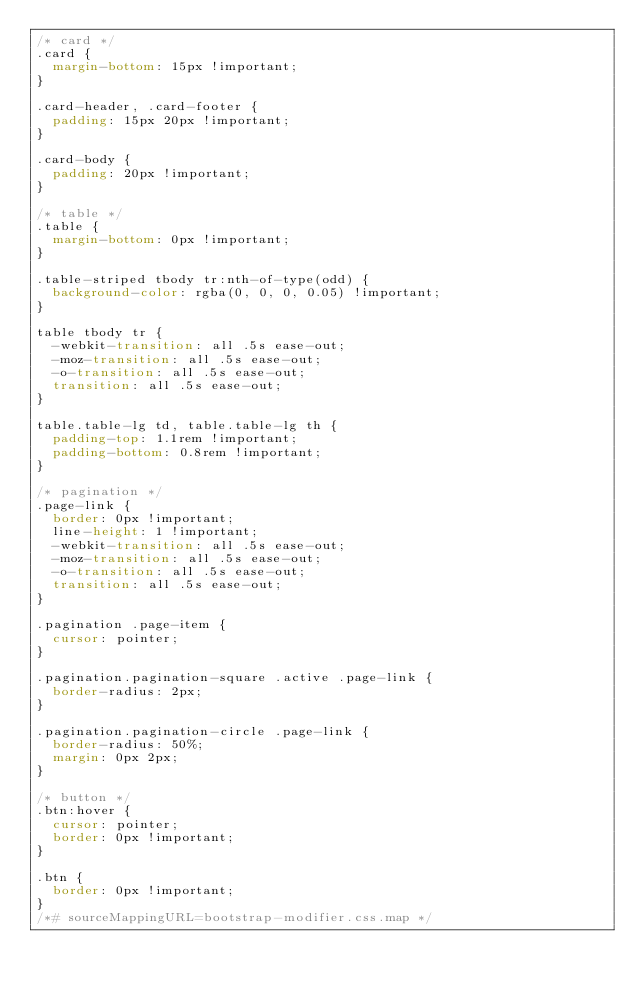Convert code to text. <code><loc_0><loc_0><loc_500><loc_500><_CSS_>/* card */
.card {
  margin-bottom: 15px !important;
}

.card-header, .card-footer {
  padding: 15px 20px !important;
}

.card-body {
  padding: 20px !important;
}

/* table */
.table {
  margin-bottom: 0px !important;
}

.table-striped tbody tr:nth-of-type(odd) {
  background-color: rgba(0, 0, 0, 0.05) !important;
}

table tbody tr {
  -webkit-transition: all .5s ease-out;
  -moz-transition: all .5s ease-out;
  -o-transition: all .5s ease-out;
  transition: all .5s ease-out;
}

table.table-lg td, table.table-lg th {
  padding-top: 1.1rem !important;
  padding-bottom: 0.8rem !important;
}

/* pagination */
.page-link {
  border: 0px !important;
  line-height: 1 !important;
  -webkit-transition: all .5s ease-out;
  -moz-transition: all .5s ease-out;
  -o-transition: all .5s ease-out;
  transition: all .5s ease-out;
}

.pagination .page-item {
  cursor: pointer;
}

.pagination.pagination-square .active .page-link {
  border-radius: 2px;
}

.pagination.pagination-circle .page-link {
  border-radius: 50%;
  margin: 0px 2px;
}

/* button */
.btn:hover {
  cursor: pointer;
  border: 0px !important;
}

.btn {
  border: 0px !important;
}
/*# sourceMappingURL=bootstrap-modifier.css.map */</code> 